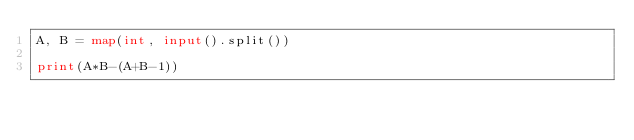<code> <loc_0><loc_0><loc_500><loc_500><_Python_>A, B = map(int, input().split())

print(A*B-(A+B-1))</code> 